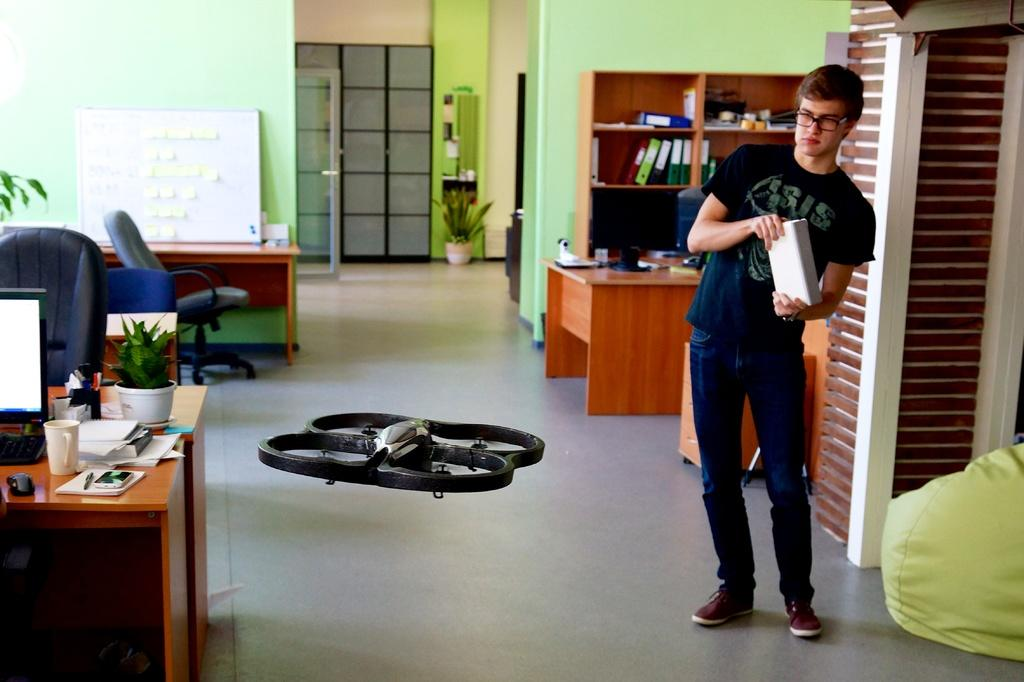What is the position of the person in the image? The person is standing at the left side of the image. What is the person standing near in the image? The person is standing near a system in the image. What can be seen in the background of the image? There are books visible in the background of the image. What type of trees can be seen growing in the image? There are no trees visible in the image. Is the person wearing a vest in the image? The provided facts do not mention any clothing details about the person, so it cannot be determined if they are wearing a vest. 